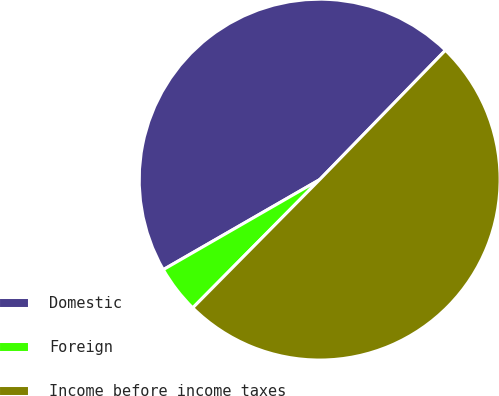<chart> <loc_0><loc_0><loc_500><loc_500><pie_chart><fcel>Domestic<fcel>Foreign<fcel>Income before income taxes<nl><fcel>45.59%<fcel>4.27%<fcel>50.14%<nl></chart> 